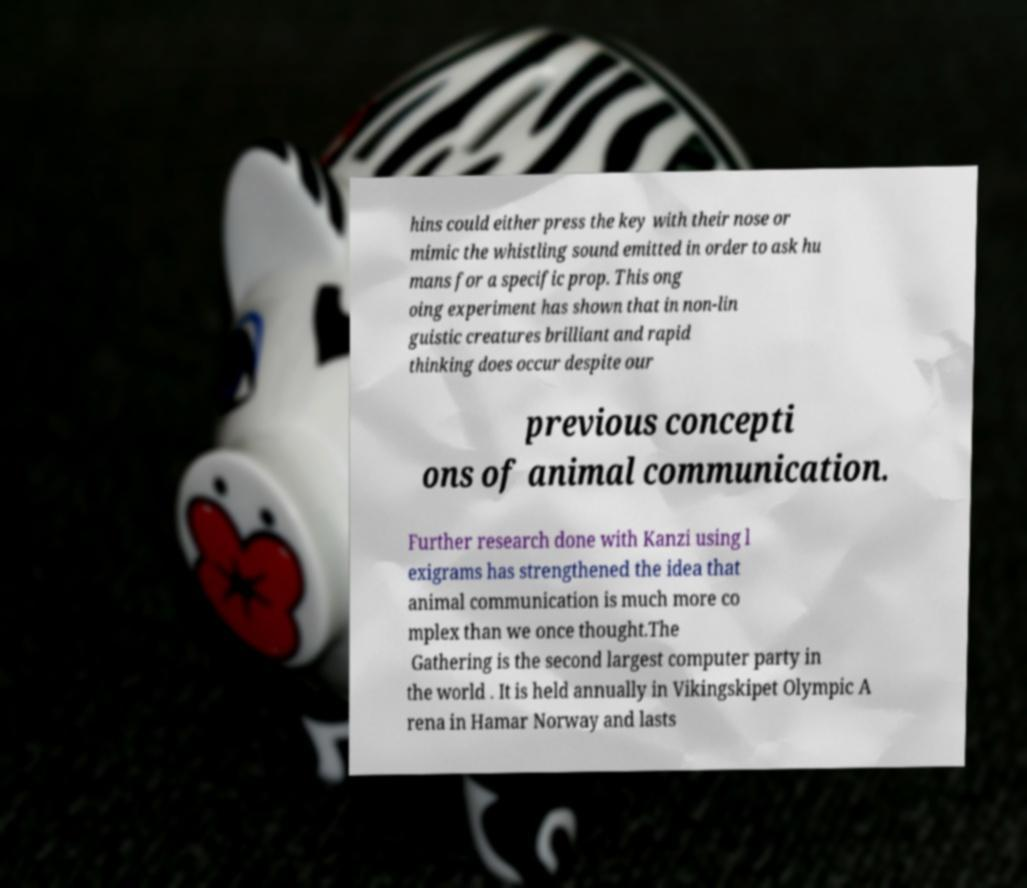For documentation purposes, I need the text within this image transcribed. Could you provide that? hins could either press the key with their nose or mimic the whistling sound emitted in order to ask hu mans for a specific prop. This ong oing experiment has shown that in non-lin guistic creatures brilliant and rapid thinking does occur despite our previous concepti ons of animal communication. Further research done with Kanzi using l exigrams has strengthened the idea that animal communication is much more co mplex than we once thought.The Gathering is the second largest computer party in the world . It is held annually in Vikingskipet Olympic A rena in Hamar Norway and lasts 